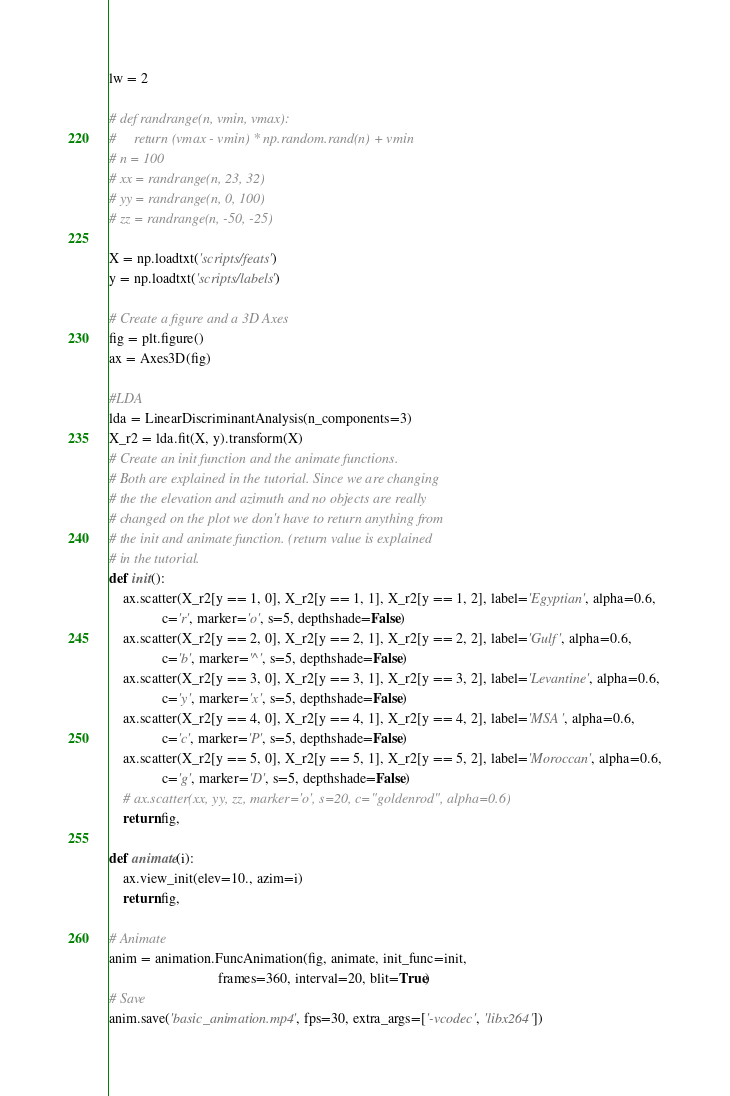Convert code to text. <code><loc_0><loc_0><loc_500><loc_500><_Python_>
lw = 2

# def randrange(n, vmin, vmax):
#     return (vmax - vmin) * np.random.rand(n) + vmin
# n = 100
# xx = randrange(n, 23, 32)
# yy = randrange(n, 0, 100)
# zz = randrange(n, -50, -25)

X = np.loadtxt('scripts/feats')
y = np.loadtxt('scripts/labels')

# Create a figure and a 3D Axes
fig = plt.figure()
ax = Axes3D(fig)

#LDA
lda = LinearDiscriminantAnalysis(n_components=3)
X_r2 = lda.fit(X, y).transform(X)
# Create an init function and the animate functions.
# Both are explained in the tutorial. Since we are changing
# the the elevation and azimuth and no objects are really
# changed on the plot we don't have to return anything from
# the init and animate function. (return value is explained
# in the tutorial.
def init():
    ax.scatter(X_r2[y == 1, 0], X_r2[y == 1, 1], X_r2[y == 1, 2], label='Egyptian', alpha=0.6,
               c='r', marker='o', s=5, depthshade=False)
    ax.scatter(X_r2[y == 2, 0], X_r2[y == 2, 1], X_r2[y == 2, 2], label='Gulf', alpha=0.6,
               c='b', marker='^', s=5, depthshade=False)
    ax.scatter(X_r2[y == 3, 0], X_r2[y == 3, 1], X_r2[y == 3, 2], label='Levantine', alpha=0.6,
               c='y', marker='x', s=5, depthshade=False)
    ax.scatter(X_r2[y == 4, 0], X_r2[y == 4, 1], X_r2[y == 4, 2], label='MSA', alpha=0.6,
               c='c', marker='P', s=5, depthshade=False)
    ax.scatter(X_r2[y == 5, 0], X_r2[y == 5, 1], X_r2[y == 5, 2], label='Moroccan', alpha=0.6,
               c='g', marker='D', s=5, depthshade=False)
    # ax.scatter(xx, yy, zz, marker='o', s=20, c="goldenrod", alpha=0.6)
    return fig,

def animate(i):
    ax.view_init(elev=10., azim=i)
    return fig,

# Animate
anim = animation.FuncAnimation(fig, animate, init_func=init,
                               frames=360, interval=20, blit=True)
# Save
anim.save('basic_animation.mp4', fps=30, extra_args=['-vcodec', 'libx264'])</code> 